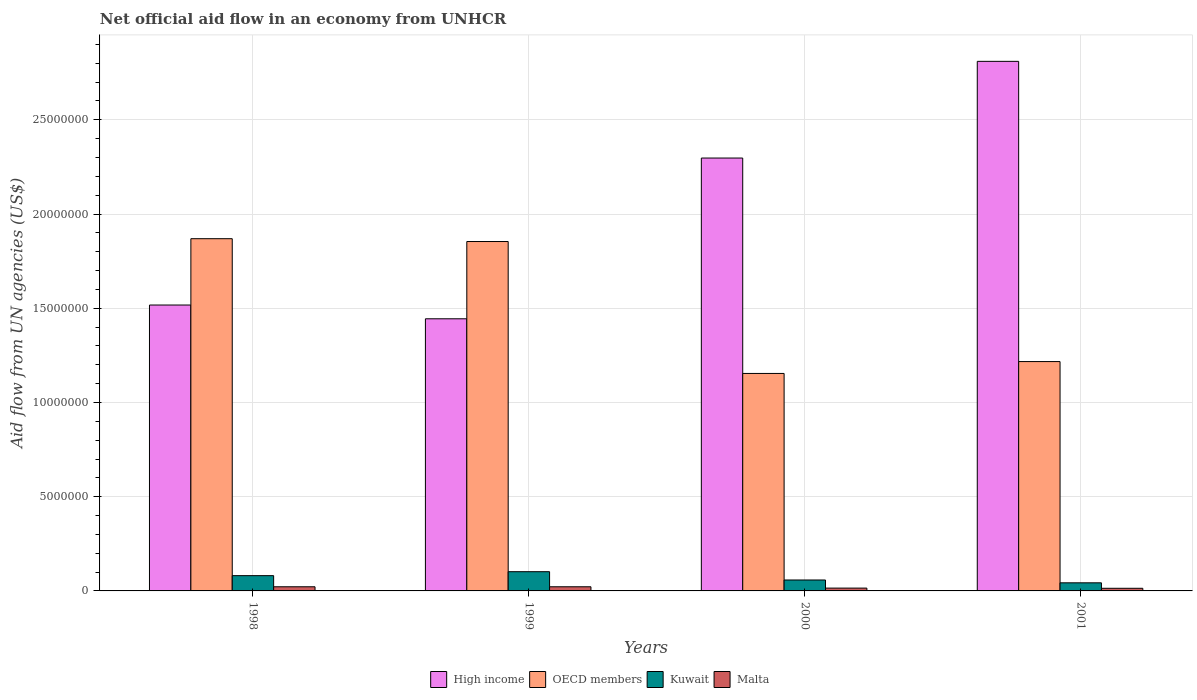How many bars are there on the 3rd tick from the left?
Your response must be concise. 4. In how many cases, is the number of bars for a given year not equal to the number of legend labels?
Provide a short and direct response. 0. What is the net official aid flow in Malta in 1998?
Offer a very short reply. 2.20e+05. Across all years, what is the maximum net official aid flow in High income?
Give a very brief answer. 2.81e+07. Across all years, what is the minimum net official aid flow in OECD members?
Your answer should be compact. 1.15e+07. What is the total net official aid flow in Malta in the graph?
Your response must be concise. 7.30e+05. What is the difference between the net official aid flow in High income in 1998 and that in 2000?
Provide a succinct answer. -7.80e+06. What is the difference between the net official aid flow in OECD members in 2001 and the net official aid flow in Malta in 1999?
Make the answer very short. 1.20e+07. What is the average net official aid flow in Malta per year?
Keep it short and to the point. 1.82e+05. In the year 2000, what is the difference between the net official aid flow in High income and net official aid flow in Malta?
Make the answer very short. 2.28e+07. What is the ratio of the net official aid flow in High income in 1999 to that in 2001?
Your answer should be very brief. 0.51. Is the difference between the net official aid flow in High income in 1998 and 1999 greater than the difference between the net official aid flow in Malta in 1998 and 1999?
Your response must be concise. Yes. What is the difference between the highest and the lowest net official aid flow in Malta?
Offer a terse response. 8.00e+04. In how many years, is the net official aid flow in Malta greater than the average net official aid flow in Malta taken over all years?
Make the answer very short. 2. What does the 4th bar from the right in 2000 represents?
Give a very brief answer. High income. Is it the case that in every year, the sum of the net official aid flow in OECD members and net official aid flow in Kuwait is greater than the net official aid flow in High income?
Your answer should be compact. No. Does the graph contain grids?
Your answer should be compact. Yes. What is the title of the graph?
Keep it short and to the point. Net official aid flow in an economy from UNHCR. What is the label or title of the Y-axis?
Your response must be concise. Aid flow from UN agencies (US$). What is the Aid flow from UN agencies (US$) in High income in 1998?
Provide a succinct answer. 1.52e+07. What is the Aid flow from UN agencies (US$) of OECD members in 1998?
Keep it short and to the point. 1.87e+07. What is the Aid flow from UN agencies (US$) in Kuwait in 1998?
Your answer should be very brief. 8.10e+05. What is the Aid flow from UN agencies (US$) of High income in 1999?
Make the answer very short. 1.44e+07. What is the Aid flow from UN agencies (US$) in OECD members in 1999?
Offer a very short reply. 1.85e+07. What is the Aid flow from UN agencies (US$) in Kuwait in 1999?
Make the answer very short. 1.02e+06. What is the Aid flow from UN agencies (US$) in Malta in 1999?
Make the answer very short. 2.20e+05. What is the Aid flow from UN agencies (US$) in High income in 2000?
Your answer should be very brief. 2.30e+07. What is the Aid flow from UN agencies (US$) of OECD members in 2000?
Ensure brevity in your answer.  1.15e+07. What is the Aid flow from UN agencies (US$) of Kuwait in 2000?
Ensure brevity in your answer.  5.80e+05. What is the Aid flow from UN agencies (US$) in Malta in 2000?
Provide a succinct answer. 1.50e+05. What is the Aid flow from UN agencies (US$) in High income in 2001?
Provide a succinct answer. 2.81e+07. What is the Aid flow from UN agencies (US$) in OECD members in 2001?
Make the answer very short. 1.22e+07. What is the Aid flow from UN agencies (US$) of Kuwait in 2001?
Make the answer very short. 4.30e+05. Across all years, what is the maximum Aid flow from UN agencies (US$) in High income?
Your answer should be very brief. 2.81e+07. Across all years, what is the maximum Aid flow from UN agencies (US$) of OECD members?
Offer a terse response. 1.87e+07. Across all years, what is the maximum Aid flow from UN agencies (US$) of Kuwait?
Offer a very short reply. 1.02e+06. Across all years, what is the minimum Aid flow from UN agencies (US$) in High income?
Ensure brevity in your answer.  1.44e+07. Across all years, what is the minimum Aid flow from UN agencies (US$) in OECD members?
Your response must be concise. 1.15e+07. Across all years, what is the minimum Aid flow from UN agencies (US$) of Kuwait?
Provide a short and direct response. 4.30e+05. Across all years, what is the minimum Aid flow from UN agencies (US$) of Malta?
Provide a short and direct response. 1.40e+05. What is the total Aid flow from UN agencies (US$) in High income in the graph?
Give a very brief answer. 8.07e+07. What is the total Aid flow from UN agencies (US$) in OECD members in the graph?
Provide a succinct answer. 6.09e+07. What is the total Aid flow from UN agencies (US$) of Kuwait in the graph?
Your answer should be very brief. 2.84e+06. What is the total Aid flow from UN agencies (US$) in Malta in the graph?
Keep it short and to the point. 7.30e+05. What is the difference between the Aid flow from UN agencies (US$) of High income in 1998 and that in 1999?
Offer a very short reply. 7.30e+05. What is the difference between the Aid flow from UN agencies (US$) in Kuwait in 1998 and that in 1999?
Keep it short and to the point. -2.10e+05. What is the difference between the Aid flow from UN agencies (US$) in Malta in 1998 and that in 1999?
Make the answer very short. 0. What is the difference between the Aid flow from UN agencies (US$) of High income in 1998 and that in 2000?
Provide a succinct answer. -7.80e+06. What is the difference between the Aid flow from UN agencies (US$) of OECD members in 1998 and that in 2000?
Your answer should be compact. 7.15e+06. What is the difference between the Aid flow from UN agencies (US$) in High income in 1998 and that in 2001?
Your answer should be very brief. -1.29e+07. What is the difference between the Aid flow from UN agencies (US$) in OECD members in 1998 and that in 2001?
Offer a very short reply. 6.52e+06. What is the difference between the Aid flow from UN agencies (US$) in Kuwait in 1998 and that in 2001?
Keep it short and to the point. 3.80e+05. What is the difference between the Aid flow from UN agencies (US$) of Malta in 1998 and that in 2001?
Provide a short and direct response. 8.00e+04. What is the difference between the Aid flow from UN agencies (US$) in High income in 1999 and that in 2000?
Keep it short and to the point. -8.53e+06. What is the difference between the Aid flow from UN agencies (US$) in OECD members in 1999 and that in 2000?
Offer a terse response. 7.00e+06. What is the difference between the Aid flow from UN agencies (US$) of High income in 1999 and that in 2001?
Ensure brevity in your answer.  -1.37e+07. What is the difference between the Aid flow from UN agencies (US$) of OECD members in 1999 and that in 2001?
Offer a terse response. 6.37e+06. What is the difference between the Aid flow from UN agencies (US$) of Kuwait in 1999 and that in 2001?
Provide a short and direct response. 5.90e+05. What is the difference between the Aid flow from UN agencies (US$) of High income in 2000 and that in 2001?
Provide a succinct answer. -5.13e+06. What is the difference between the Aid flow from UN agencies (US$) in OECD members in 2000 and that in 2001?
Your answer should be very brief. -6.30e+05. What is the difference between the Aid flow from UN agencies (US$) in High income in 1998 and the Aid flow from UN agencies (US$) in OECD members in 1999?
Make the answer very short. -3.37e+06. What is the difference between the Aid flow from UN agencies (US$) of High income in 1998 and the Aid flow from UN agencies (US$) of Kuwait in 1999?
Your answer should be very brief. 1.42e+07. What is the difference between the Aid flow from UN agencies (US$) in High income in 1998 and the Aid flow from UN agencies (US$) in Malta in 1999?
Provide a succinct answer. 1.50e+07. What is the difference between the Aid flow from UN agencies (US$) of OECD members in 1998 and the Aid flow from UN agencies (US$) of Kuwait in 1999?
Keep it short and to the point. 1.77e+07. What is the difference between the Aid flow from UN agencies (US$) in OECD members in 1998 and the Aid flow from UN agencies (US$) in Malta in 1999?
Ensure brevity in your answer.  1.85e+07. What is the difference between the Aid flow from UN agencies (US$) of Kuwait in 1998 and the Aid flow from UN agencies (US$) of Malta in 1999?
Make the answer very short. 5.90e+05. What is the difference between the Aid flow from UN agencies (US$) in High income in 1998 and the Aid flow from UN agencies (US$) in OECD members in 2000?
Your answer should be compact. 3.63e+06. What is the difference between the Aid flow from UN agencies (US$) of High income in 1998 and the Aid flow from UN agencies (US$) of Kuwait in 2000?
Offer a terse response. 1.46e+07. What is the difference between the Aid flow from UN agencies (US$) in High income in 1998 and the Aid flow from UN agencies (US$) in Malta in 2000?
Your answer should be very brief. 1.50e+07. What is the difference between the Aid flow from UN agencies (US$) in OECD members in 1998 and the Aid flow from UN agencies (US$) in Kuwait in 2000?
Your response must be concise. 1.81e+07. What is the difference between the Aid flow from UN agencies (US$) of OECD members in 1998 and the Aid flow from UN agencies (US$) of Malta in 2000?
Give a very brief answer. 1.85e+07. What is the difference between the Aid flow from UN agencies (US$) of Kuwait in 1998 and the Aid flow from UN agencies (US$) of Malta in 2000?
Give a very brief answer. 6.60e+05. What is the difference between the Aid flow from UN agencies (US$) in High income in 1998 and the Aid flow from UN agencies (US$) in Kuwait in 2001?
Your answer should be compact. 1.47e+07. What is the difference between the Aid flow from UN agencies (US$) in High income in 1998 and the Aid flow from UN agencies (US$) in Malta in 2001?
Make the answer very short. 1.50e+07. What is the difference between the Aid flow from UN agencies (US$) of OECD members in 1998 and the Aid flow from UN agencies (US$) of Kuwait in 2001?
Provide a succinct answer. 1.83e+07. What is the difference between the Aid flow from UN agencies (US$) of OECD members in 1998 and the Aid flow from UN agencies (US$) of Malta in 2001?
Make the answer very short. 1.86e+07. What is the difference between the Aid flow from UN agencies (US$) in Kuwait in 1998 and the Aid flow from UN agencies (US$) in Malta in 2001?
Provide a succinct answer. 6.70e+05. What is the difference between the Aid flow from UN agencies (US$) in High income in 1999 and the Aid flow from UN agencies (US$) in OECD members in 2000?
Ensure brevity in your answer.  2.90e+06. What is the difference between the Aid flow from UN agencies (US$) in High income in 1999 and the Aid flow from UN agencies (US$) in Kuwait in 2000?
Keep it short and to the point. 1.39e+07. What is the difference between the Aid flow from UN agencies (US$) of High income in 1999 and the Aid flow from UN agencies (US$) of Malta in 2000?
Provide a short and direct response. 1.43e+07. What is the difference between the Aid flow from UN agencies (US$) in OECD members in 1999 and the Aid flow from UN agencies (US$) in Kuwait in 2000?
Offer a terse response. 1.80e+07. What is the difference between the Aid flow from UN agencies (US$) of OECD members in 1999 and the Aid flow from UN agencies (US$) of Malta in 2000?
Keep it short and to the point. 1.84e+07. What is the difference between the Aid flow from UN agencies (US$) of Kuwait in 1999 and the Aid flow from UN agencies (US$) of Malta in 2000?
Provide a short and direct response. 8.70e+05. What is the difference between the Aid flow from UN agencies (US$) of High income in 1999 and the Aid flow from UN agencies (US$) of OECD members in 2001?
Offer a very short reply. 2.27e+06. What is the difference between the Aid flow from UN agencies (US$) of High income in 1999 and the Aid flow from UN agencies (US$) of Kuwait in 2001?
Offer a very short reply. 1.40e+07. What is the difference between the Aid flow from UN agencies (US$) in High income in 1999 and the Aid flow from UN agencies (US$) in Malta in 2001?
Your response must be concise. 1.43e+07. What is the difference between the Aid flow from UN agencies (US$) of OECD members in 1999 and the Aid flow from UN agencies (US$) of Kuwait in 2001?
Give a very brief answer. 1.81e+07. What is the difference between the Aid flow from UN agencies (US$) of OECD members in 1999 and the Aid flow from UN agencies (US$) of Malta in 2001?
Your answer should be compact. 1.84e+07. What is the difference between the Aid flow from UN agencies (US$) in Kuwait in 1999 and the Aid flow from UN agencies (US$) in Malta in 2001?
Your response must be concise. 8.80e+05. What is the difference between the Aid flow from UN agencies (US$) in High income in 2000 and the Aid flow from UN agencies (US$) in OECD members in 2001?
Your response must be concise. 1.08e+07. What is the difference between the Aid flow from UN agencies (US$) of High income in 2000 and the Aid flow from UN agencies (US$) of Kuwait in 2001?
Offer a terse response. 2.25e+07. What is the difference between the Aid flow from UN agencies (US$) in High income in 2000 and the Aid flow from UN agencies (US$) in Malta in 2001?
Provide a succinct answer. 2.28e+07. What is the difference between the Aid flow from UN agencies (US$) of OECD members in 2000 and the Aid flow from UN agencies (US$) of Kuwait in 2001?
Your answer should be compact. 1.11e+07. What is the difference between the Aid flow from UN agencies (US$) of OECD members in 2000 and the Aid flow from UN agencies (US$) of Malta in 2001?
Your response must be concise. 1.14e+07. What is the average Aid flow from UN agencies (US$) of High income per year?
Ensure brevity in your answer.  2.02e+07. What is the average Aid flow from UN agencies (US$) in OECD members per year?
Give a very brief answer. 1.52e+07. What is the average Aid flow from UN agencies (US$) in Kuwait per year?
Give a very brief answer. 7.10e+05. What is the average Aid flow from UN agencies (US$) in Malta per year?
Provide a short and direct response. 1.82e+05. In the year 1998, what is the difference between the Aid flow from UN agencies (US$) in High income and Aid flow from UN agencies (US$) in OECD members?
Your answer should be compact. -3.52e+06. In the year 1998, what is the difference between the Aid flow from UN agencies (US$) in High income and Aid flow from UN agencies (US$) in Kuwait?
Offer a terse response. 1.44e+07. In the year 1998, what is the difference between the Aid flow from UN agencies (US$) of High income and Aid flow from UN agencies (US$) of Malta?
Give a very brief answer. 1.50e+07. In the year 1998, what is the difference between the Aid flow from UN agencies (US$) of OECD members and Aid flow from UN agencies (US$) of Kuwait?
Provide a succinct answer. 1.79e+07. In the year 1998, what is the difference between the Aid flow from UN agencies (US$) of OECD members and Aid flow from UN agencies (US$) of Malta?
Your response must be concise. 1.85e+07. In the year 1998, what is the difference between the Aid flow from UN agencies (US$) of Kuwait and Aid flow from UN agencies (US$) of Malta?
Provide a short and direct response. 5.90e+05. In the year 1999, what is the difference between the Aid flow from UN agencies (US$) in High income and Aid flow from UN agencies (US$) in OECD members?
Your answer should be very brief. -4.10e+06. In the year 1999, what is the difference between the Aid flow from UN agencies (US$) of High income and Aid flow from UN agencies (US$) of Kuwait?
Make the answer very short. 1.34e+07. In the year 1999, what is the difference between the Aid flow from UN agencies (US$) in High income and Aid flow from UN agencies (US$) in Malta?
Make the answer very short. 1.42e+07. In the year 1999, what is the difference between the Aid flow from UN agencies (US$) of OECD members and Aid flow from UN agencies (US$) of Kuwait?
Your response must be concise. 1.75e+07. In the year 1999, what is the difference between the Aid flow from UN agencies (US$) in OECD members and Aid flow from UN agencies (US$) in Malta?
Keep it short and to the point. 1.83e+07. In the year 2000, what is the difference between the Aid flow from UN agencies (US$) of High income and Aid flow from UN agencies (US$) of OECD members?
Keep it short and to the point. 1.14e+07. In the year 2000, what is the difference between the Aid flow from UN agencies (US$) in High income and Aid flow from UN agencies (US$) in Kuwait?
Your answer should be compact. 2.24e+07. In the year 2000, what is the difference between the Aid flow from UN agencies (US$) in High income and Aid flow from UN agencies (US$) in Malta?
Your response must be concise. 2.28e+07. In the year 2000, what is the difference between the Aid flow from UN agencies (US$) in OECD members and Aid flow from UN agencies (US$) in Kuwait?
Ensure brevity in your answer.  1.10e+07. In the year 2000, what is the difference between the Aid flow from UN agencies (US$) in OECD members and Aid flow from UN agencies (US$) in Malta?
Ensure brevity in your answer.  1.14e+07. In the year 2000, what is the difference between the Aid flow from UN agencies (US$) of Kuwait and Aid flow from UN agencies (US$) of Malta?
Offer a terse response. 4.30e+05. In the year 2001, what is the difference between the Aid flow from UN agencies (US$) of High income and Aid flow from UN agencies (US$) of OECD members?
Your response must be concise. 1.59e+07. In the year 2001, what is the difference between the Aid flow from UN agencies (US$) of High income and Aid flow from UN agencies (US$) of Kuwait?
Offer a very short reply. 2.77e+07. In the year 2001, what is the difference between the Aid flow from UN agencies (US$) in High income and Aid flow from UN agencies (US$) in Malta?
Ensure brevity in your answer.  2.80e+07. In the year 2001, what is the difference between the Aid flow from UN agencies (US$) in OECD members and Aid flow from UN agencies (US$) in Kuwait?
Offer a very short reply. 1.17e+07. In the year 2001, what is the difference between the Aid flow from UN agencies (US$) of OECD members and Aid flow from UN agencies (US$) of Malta?
Your answer should be very brief. 1.20e+07. What is the ratio of the Aid flow from UN agencies (US$) in High income in 1998 to that in 1999?
Your answer should be compact. 1.05. What is the ratio of the Aid flow from UN agencies (US$) of Kuwait in 1998 to that in 1999?
Provide a succinct answer. 0.79. What is the ratio of the Aid flow from UN agencies (US$) in High income in 1998 to that in 2000?
Provide a succinct answer. 0.66. What is the ratio of the Aid flow from UN agencies (US$) of OECD members in 1998 to that in 2000?
Make the answer very short. 1.62. What is the ratio of the Aid flow from UN agencies (US$) in Kuwait in 1998 to that in 2000?
Your answer should be compact. 1.4. What is the ratio of the Aid flow from UN agencies (US$) in Malta in 1998 to that in 2000?
Offer a terse response. 1.47. What is the ratio of the Aid flow from UN agencies (US$) of High income in 1998 to that in 2001?
Ensure brevity in your answer.  0.54. What is the ratio of the Aid flow from UN agencies (US$) of OECD members in 1998 to that in 2001?
Provide a short and direct response. 1.54. What is the ratio of the Aid flow from UN agencies (US$) of Kuwait in 1998 to that in 2001?
Make the answer very short. 1.88. What is the ratio of the Aid flow from UN agencies (US$) in Malta in 1998 to that in 2001?
Provide a succinct answer. 1.57. What is the ratio of the Aid flow from UN agencies (US$) in High income in 1999 to that in 2000?
Your answer should be very brief. 0.63. What is the ratio of the Aid flow from UN agencies (US$) of OECD members in 1999 to that in 2000?
Provide a succinct answer. 1.61. What is the ratio of the Aid flow from UN agencies (US$) in Kuwait in 1999 to that in 2000?
Your answer should be very brief. 1.76. What is the ratio of the Aid flow from UN agencies (US$) of Malta in 1999 to that in 2000?
Ensure brevity in your answer.  1.47. What is the ratio of the Aid flow from UN agencies (US$) in High income in 1999 to that in 2001?
Ensure brevity in your answer.  0.51. What is the ratio of the Aid flow from UN agencies (US$) of OECD members in 1999 to that in 2001?
Keep it short and to the point. 1.52. What is the ratio of the Aid flow from UN agencies (US$) of Kuwait in 1999 to that in 2001?
Your response must be concise. 2.37. What is the ratio of the Aid flow from UN agencies (US$) of Malta in 1999 to that in 2001?
Make the answer very short. 1.57. What is the ratio of the Aid flow from UN agencies (US$) of High income in 2000 to that in 2001?
Your answer should be very brief. 0.82. What is the ratio of the Aid flow from UN agencies (US$) in OECD members in 2000 to that in 2001?
Offer a terse response. 0.95. What is the ratio of the Aid flow from UN agencies (US$) in Kuwait in 2000 to that in 2001?
Offer a very short reply. 1.35. What is the ratio of the Aid flow from UN agencies (US$) in Malta in 2000 to that in 2001?
Provide a succinct answer. 1.07. What is the difference between the highest and the second highest Aid flow from UN agencies (US$) of High income?
Your answer should be very brief. 5.13e+06. What is the difference between the highest and the second highest Aid flow from UN agencies (US$) in OECD members?
Your answer should be compact. 1.50e+05. What is the difference between the highest and the second highest Aid flow from UN agencies (US$) of Malta?
Your response must be concise. 0. What is the difference between the highest and the lowest Aid flow from UN agencies (US$) in High income?
Make the answer very short. 1.37e+07. What is the difference between the highest and the lowest Aid flow from UN agencies (US$) in OECD members?
Your response must be concise. 7.15e+06. What is the difference between the highest and the lowest Aid flow from UN agencies (US$) of Kuwait?
Ensure brevity in your answer.  5.90e+05. 